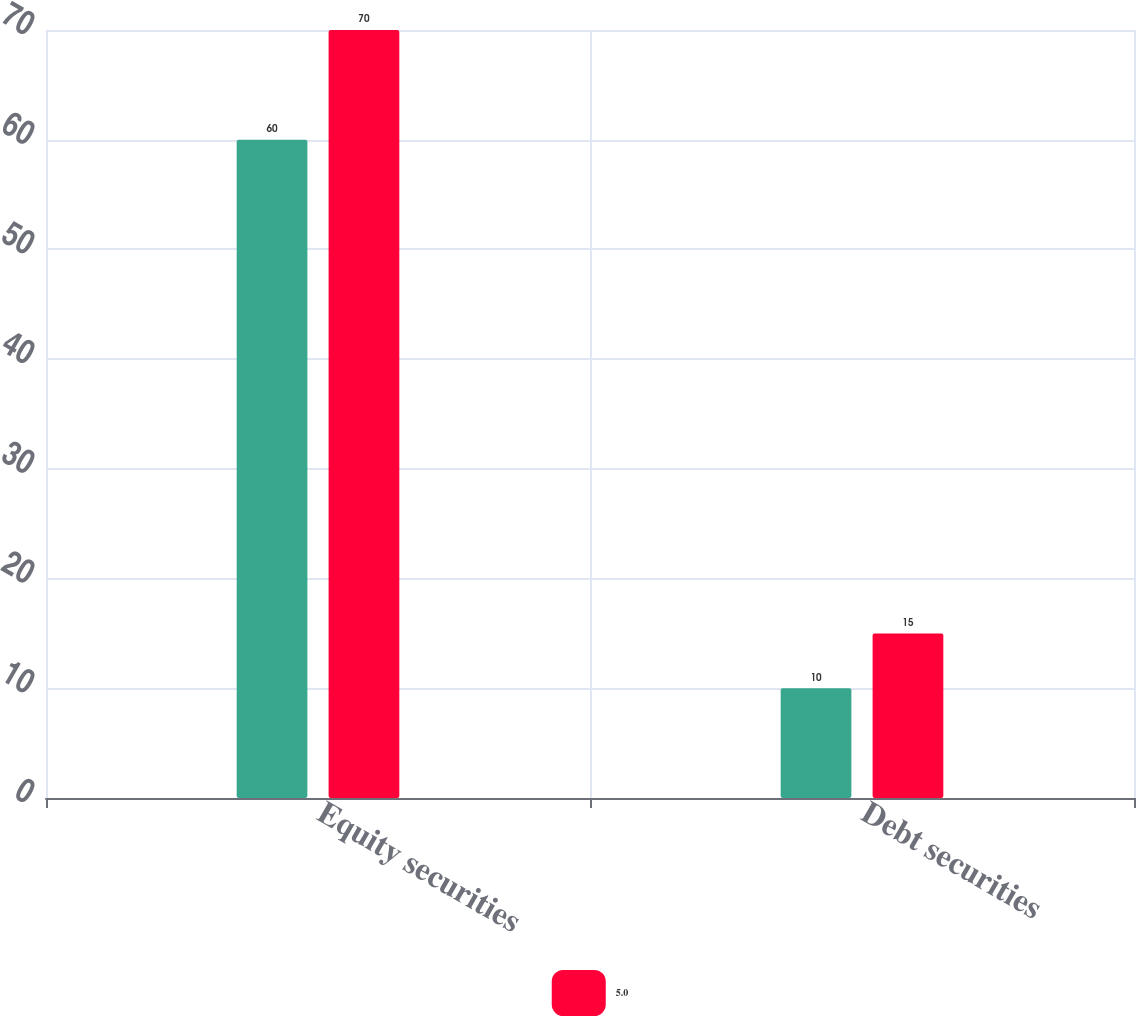<chart> <loc_0><loc_0><loc_500><loc_500><stacked_bar_chart><ecel><fcel>Equity securities<fcel>Debt securities<nl><fcel>nan<fcel>60<fcel>10<nl><fcel>5<fcel>70<fcel>15<nl></chart> 